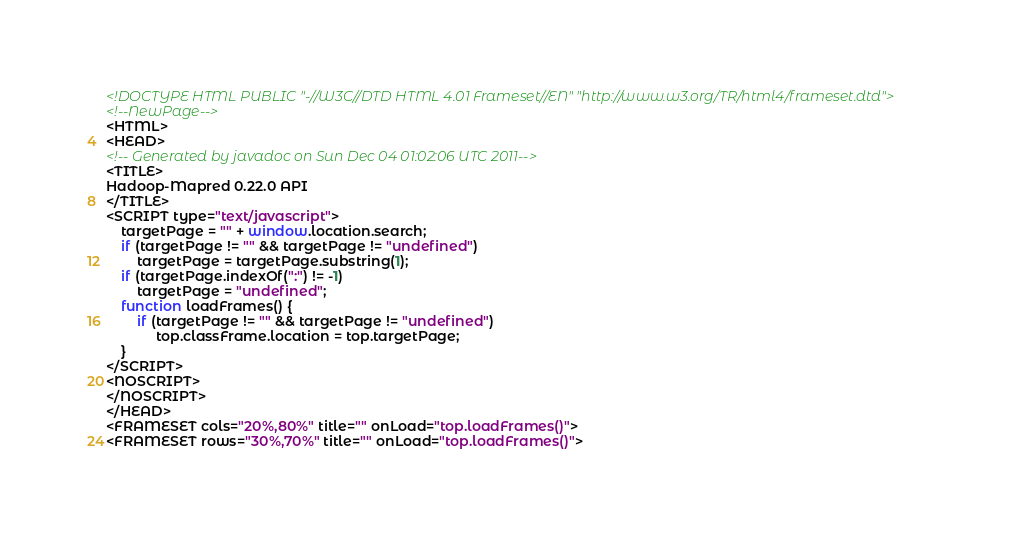Convert code to text. <code><loc_0><loc_0><loc_500><loc_500><_HTML_><!DOCTYPE HTML PUBLIC "-//W3C//DTD HTML 4.01 Frameset//EN" "http://www.w3.org/TR/html4/frameset.dtd">
<!--NewPage-->
<HTML>
<HEAD>
<!-- Generated by javadoc on Sun Dec 04 01:02:06 UTC 2011-->
<TITLE>
Hadoop-Mapred 0.22.0 API
</TITLE>
<SCRIPT type="text/javascript">
    targetPage = "" + window.location.search;
    if (targetPage != "" && targetPage != "undefined")
        targetPage = targetPage.substring(1);
    if (targetPage.indexOf(":") != -1)
        targetPage = "undefined";
    function loadFrames() {
        if (targetPage != "" && targetPage != "undefined")
             top.classFrame.location = top.targetPage;
    }
</SCRIPT>
<NOSCRIPT>
</NOSCRIPT>
</HEAD>
<FRAMESET cols="20%,80%" title="" onLoad="top.loadFrames()">
<FRAMESET rows="30%,70%" title="" onLoad="top.loadFrames()"></code> 